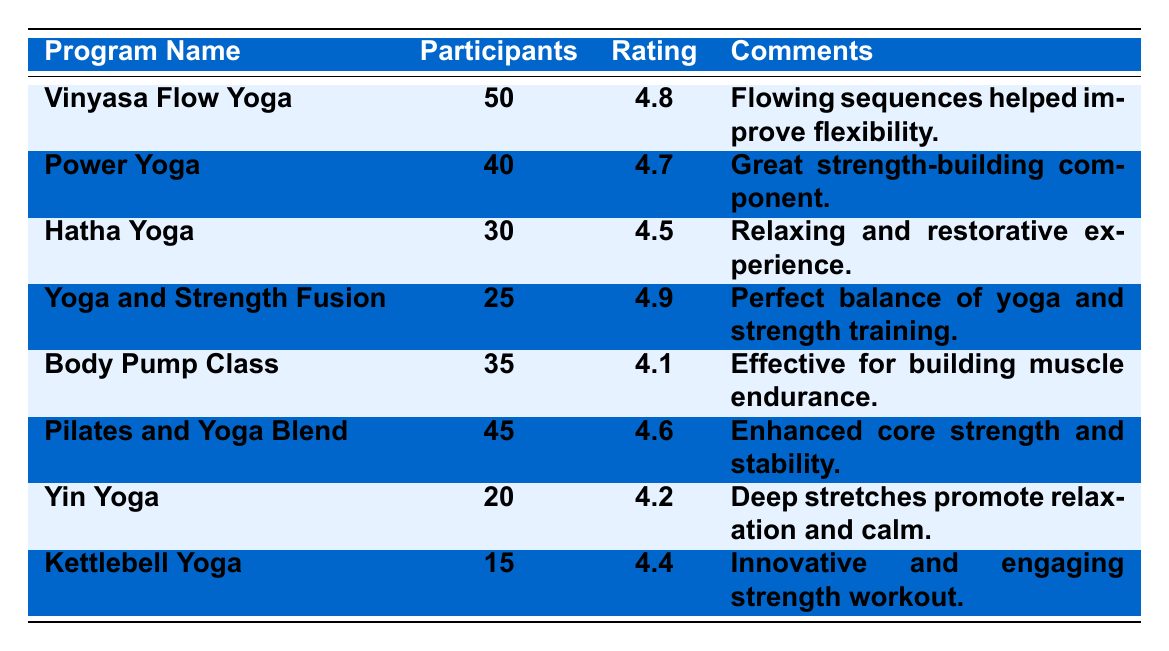What is the satisfaction rating for the Yoga and Strength Fusion program? The satisfaction rating for the Yoga and Strength Fusion program is listed directly in the table under the "Rating" column. It shows a value of 4.9.
Answer: 4.9 Which program had the lowest satisfaction rating? By reviewing the ratings in the table, the Body Pump Class has the lowest rating at 4.1, as it is the smallest number among all the ratings listed.
Answer: Body Pump Class How many more participants were in Vinyasa Flow Yoga than in Yoga and Strength Fusion? The participant counts for Vinyasa Flow Yoga and Yoga and Strength Fusion are 50 and 25, respectively. The difference is calculated by subtracting the number of participants in Yoga and Strength Fusion from Vinyasa Flow Yoga: 50 - 25 = 25.
Answer: 25 What is the average satisfaction rating of all the yoga programs listed? To find the average satisfaction rating, we first sum the ratings: 4.8 (Vinyasa Flow Yoga) + 4.7 (Power Yoga) + 4.5 (Hatha Yoga) + 4.9 (Yoga and Strength Fusion) + 4.2 (Yin Yoga) + 4.6 (Pilates and Yoga Blend) + 4.4 (Kettlebell Yoga) = 28.1. There are 7 yoga programs, so we divide the total by 7: 28.1 / 7 = 4.014285714285714, which rounds to 4.01.
Answer: 4.01 Is the satisfaction rating of Power Yoga higher than that of Yin Yoga? The satisfaction rating for Power Yoga is 4.7, and for Yin Yoga, it is 4.2. Since 4.7 is greater than 4.2, the answer is yes.
Answer: Yes What is the total number of participants across all programs? We need to sum the participants from each program: 50 (Vinyasa Flow Yoga) + 40 (Power Yoga) + 30 (Hatha Yoga) + 25 (Yoga and Strength Fusion) + 35 (Body Pump Class) + 45 (Pilates and Yoga Blend) + 20 (Yin Yoga) + 15 (Kettlebell Yoga) = 290.
Answer: 290 How does the satisfaction rating of Body Pump Class compare to the average rating of Kettlebell Yoga and Yin Yoga? The rating for Body Pump Class is 4.1. The average of Kettlebell Yoga (4.4) and Yin Yoga (4.2) is calculated as (4.4 + 4.2) / 2 = 4.3. Comparing these, 4.1 (Body Pump Class) is less than 4.3 (average of Kettlebell and Yin Yoga).
Answer: Body Pump Class is lower Which program has the highest participant count and what is its satisfaction rating? In the table, Vinyasa Flow Yoga has the highest participant count of 50, with a satisfaction rating of 4.8, as seen directly from the table.
Answer: Vinyasa Flow Yoga, 4.8 